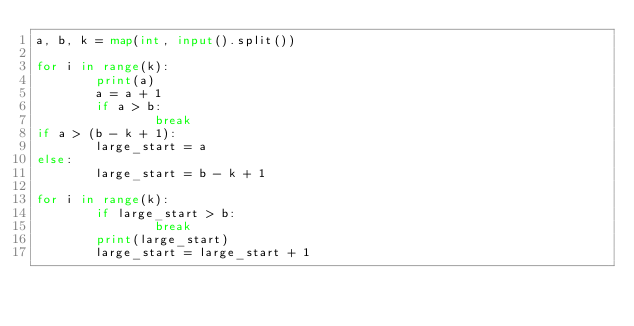<code> <loc_0><loc_0><loc_500><loc_500><_Python_>a, b, k = map(int, input().split())

for i in range(k):
        print(a)
        a = a + 1
        if a > b:
                break
if a > (b - k + 1):
        large_start = a
else:
        large_start = b - k + 1

for i in range(k):
        if large_start > b:
                break
        print(large_start)
        large_start = large_start + 1</code> 